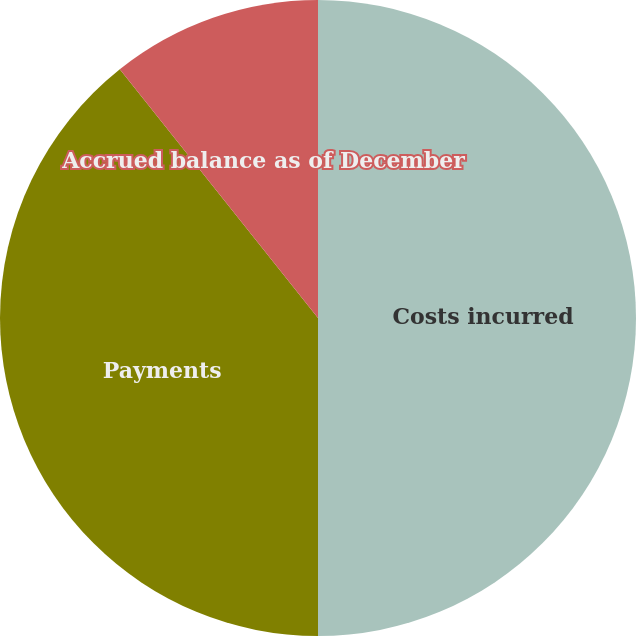Convert chart. <chart><loc_0><loc_0><loc_500><loc_500><pie_chart><fcel>Costs incurred<fcel>Payments<fcel>Accrued balance as of December<nl><fcel>50.0%<fcel>39.29%<fcel>10.71%<nl></chart> 